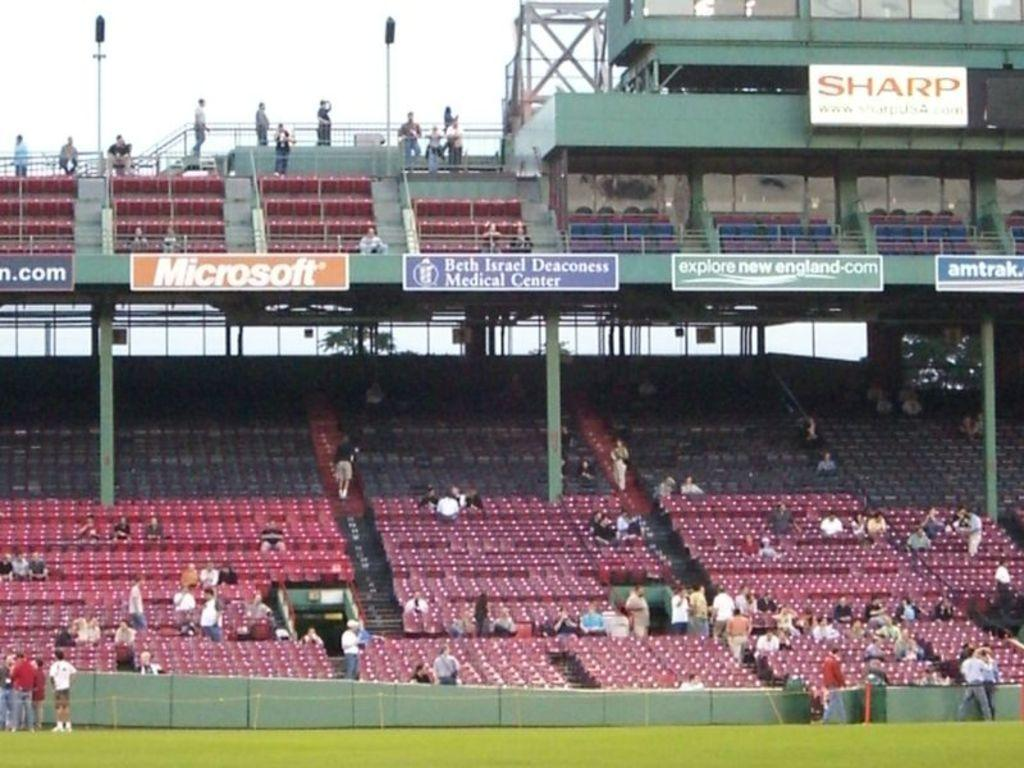<image>
Create a compact narrative representing the image presented. Various companies advertise at an outdoor stadium, including Sharp and Microsoft. 